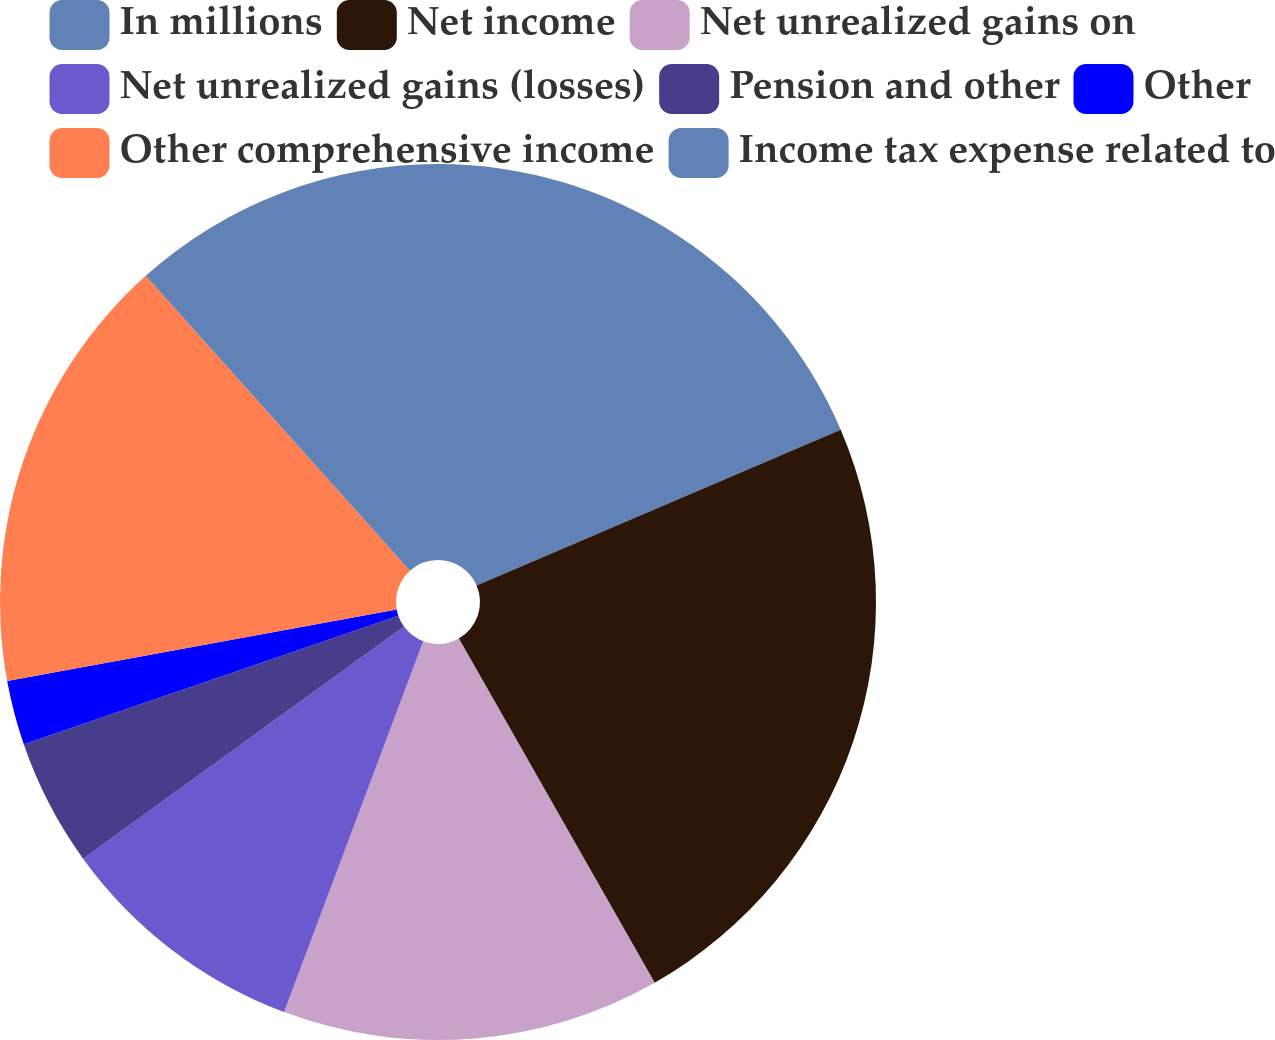Convert chart. <chart><loc_0><loc_0><loc_500><loc_500><pie_chart><fcel>In millions<fcel>Net income<fcel>Net unrealized gains on<fcel>Net unrealized gains (losses)<fcel>Pension and other<fcel>Other<fcel>Other comprehensive income<fcel>Income tax expense related to<nl><fcel>18.57%<fcel>23.2%<fcel>13.95%<fcel>9.32%<fcel>4.7%<fcel>2.38%<fcel>16.26%<fcel>11.63%<nl></chart> 